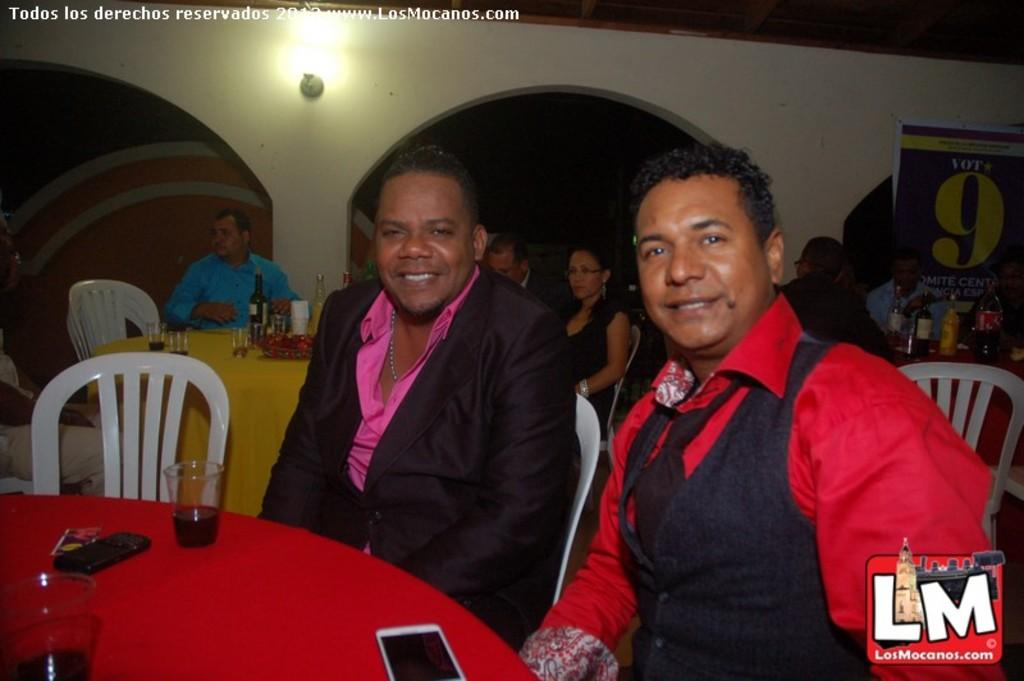What is the setting of the image? The setting of the image is a room. What are the people in the image doing? The people in the image are sitting in chairs. What is present in front of the chairs? There is a table in front of the chairs. What type of cushion is visible on the head of one of the people in the image? There is no cushion visible on the head of any of the people in the image. What kind of horn can be seen being played by one of the people in the image? There is no horn present in the image; the people are sitting in chairs and there is a table in front of them. 